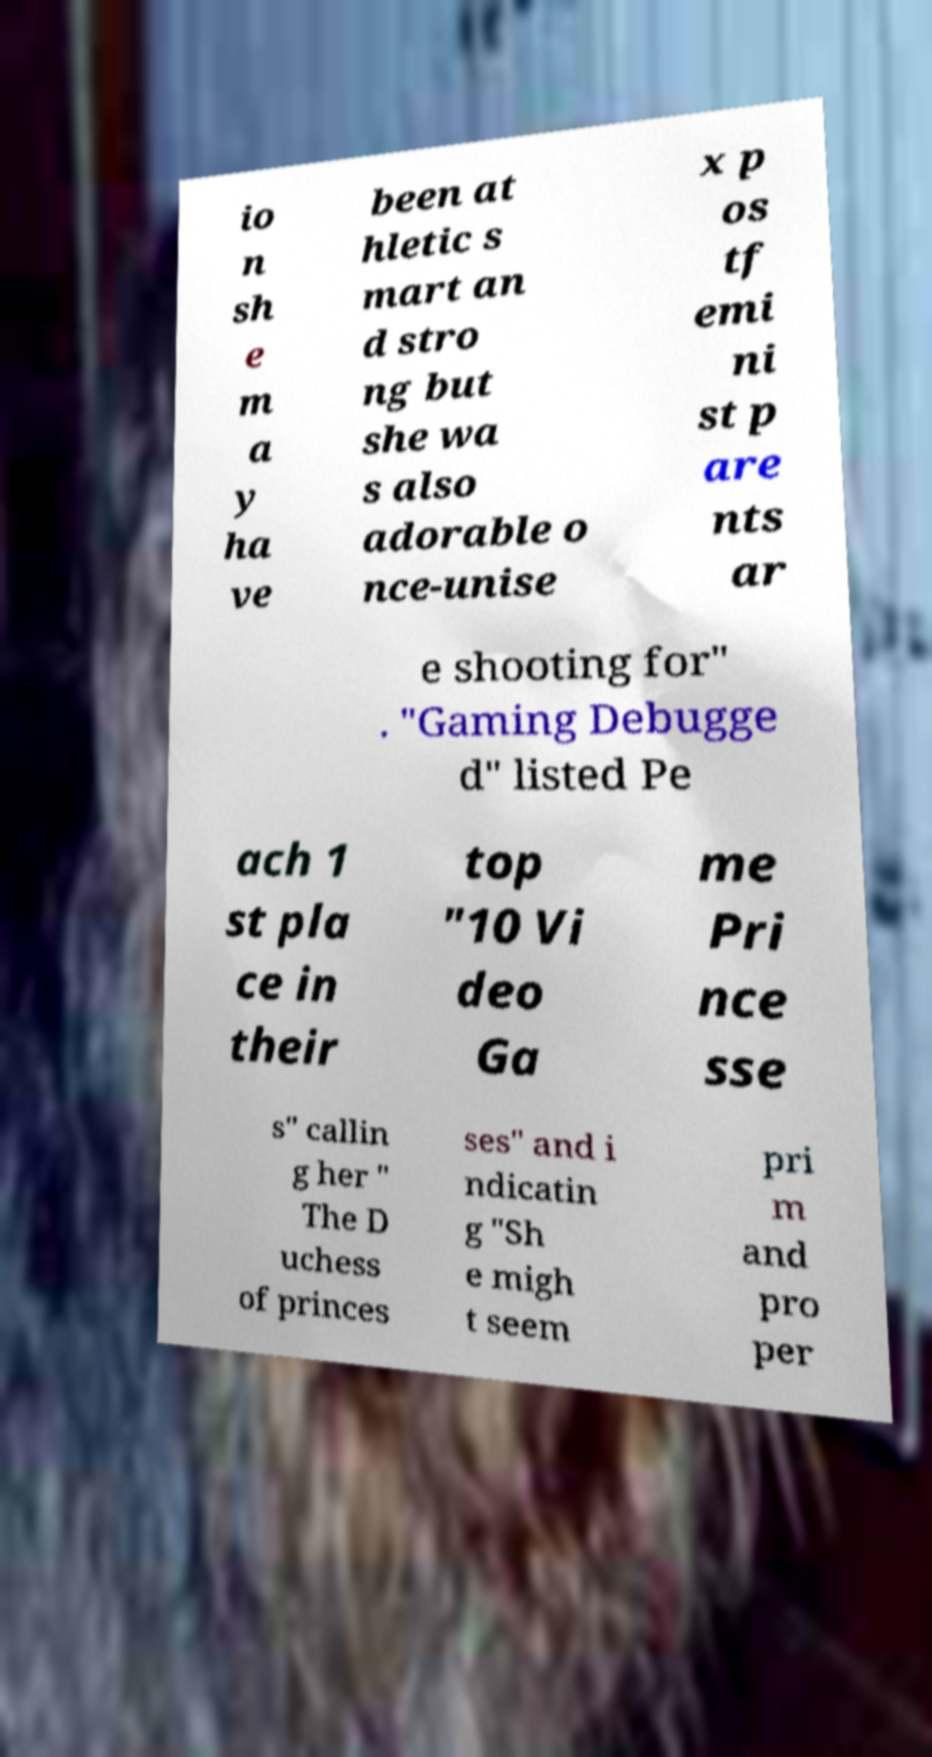What messages or text are displayed in this image? I need them in a readable, typed format. io n sh e m a y ha ve been at hletic s mart an d stro ng but she wa s also adorable o nce-unise x p os tf emi ni st p are nts ar e shooting for" . "Gaming Debugge d" listed Pe ach 1 st pla ce in their top "10 Vi deo Ga me Pri nce sse s" callin g her " The D uchess of princes ses" and i ndicatin g "Sh e migh t seem pri m and pro per 